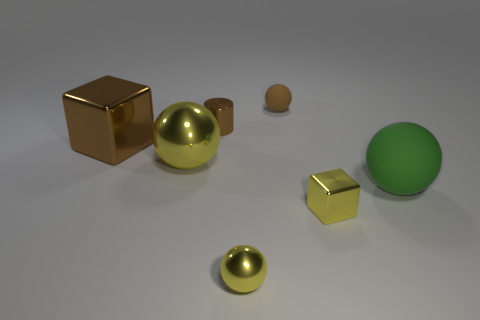Subtract all small metallic spheres. How many spheres are left? 3 Subtract all brown blocks. How many blocks are left? 1 Subtract all cylinders. How many objects are left? 6 Subtract 1 blocks. How many blocks are left? 1 Subtract all gray cylinders. Subtract all yellow spheres. How many cylinders are left? 1 Subtract all purple cubes. How many blue cylinders are left? 0 Subtract all shiny spheres. Subtract all big green spheres. How many objects are left? 4 Add 4 green rubber balls. How many green rubber balls are left? 5 Add 7 green matte objects. How many green matte objects exist? 8 Add 2 large yellow metallic things. How many objects exist? 9 